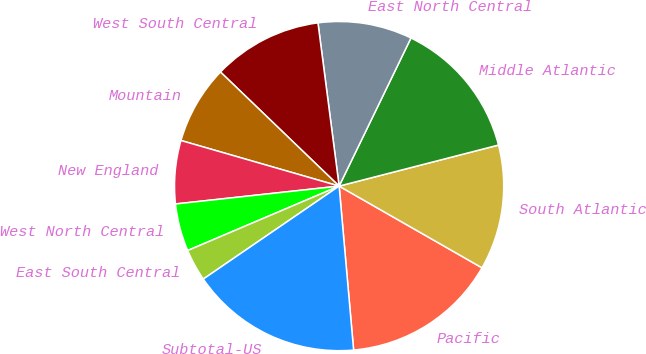Convert chart. <chart><loc_0><loc_0><loc_500><loc_500><pie_chart><fcel>Pacific<fcel>South Atlantic<fcel>Middle Atlantic<fcel>East North Central<fcel>West South Central<fcel>Mountain<fcel>New England<fcel>West North Central<fcel>East South Central<fcel>Subtotal-US<nl><fcel>15.33%<fcel>12.28%<fcel>13.8%<fcel>9.24%<fcel>10.76%<fcel>7.72%<fcel>6.2%<fcel>4.67%<fcel>3.15%<fcel>16.85%<nl></chart> 